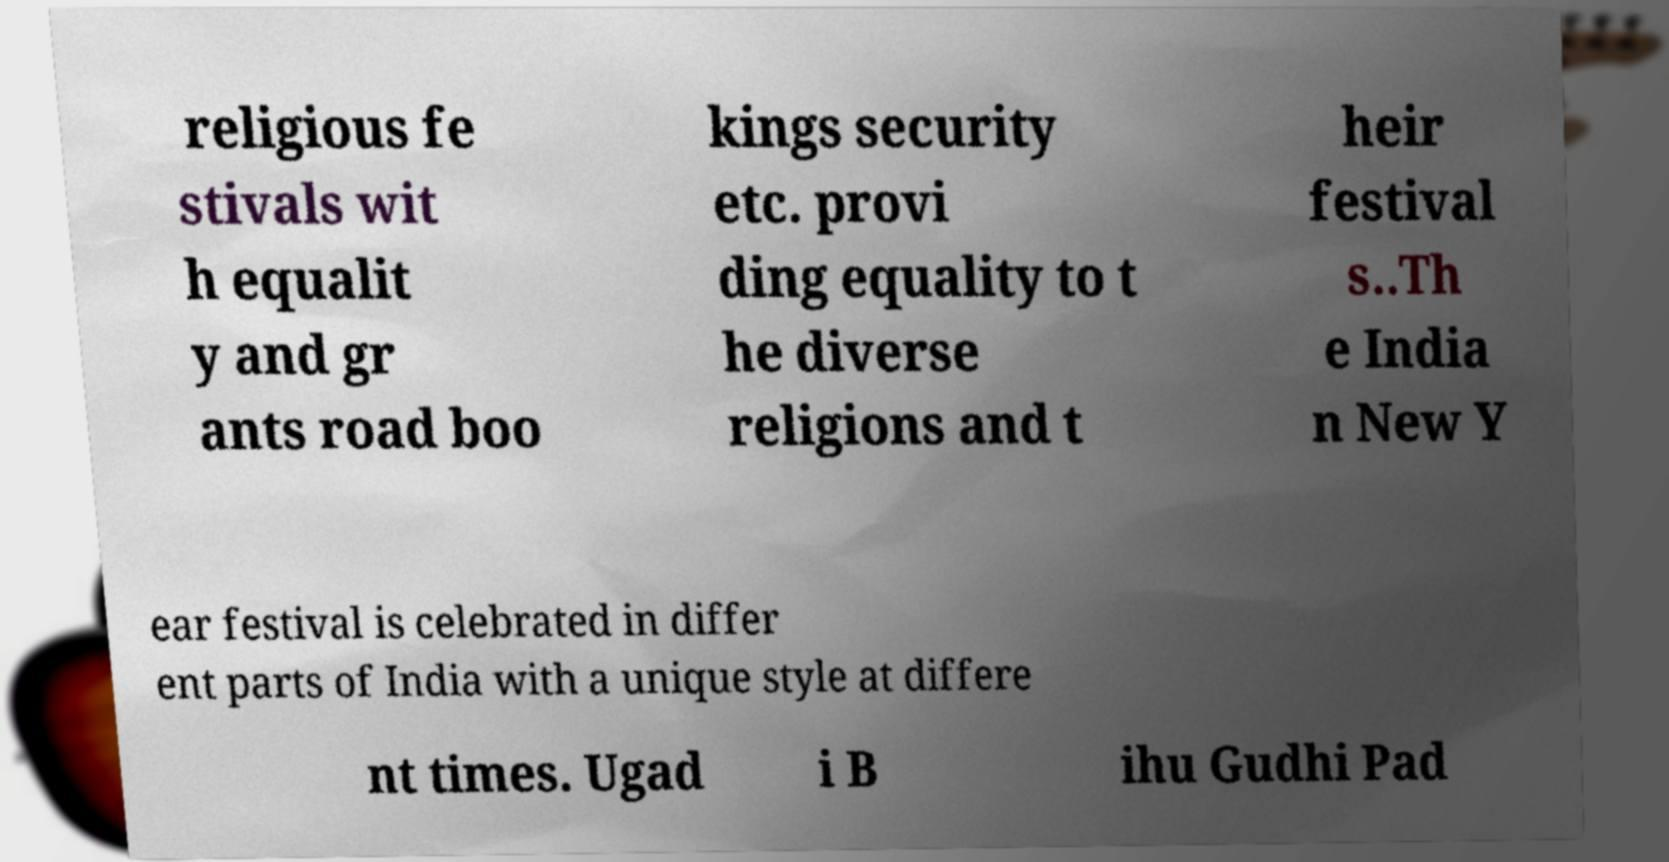Please read and relay the text visible in this image. What does it say? religious fe stivals wit h equalit y and gr ants road boo kings security etc. provi ding equality to t he diverse religions and t heir festival s..Th e India n New Y ear festival is celebrated in differ ent parts of India with a unique style at differe nt times. Ugad i B ihu Gudhi Pad 